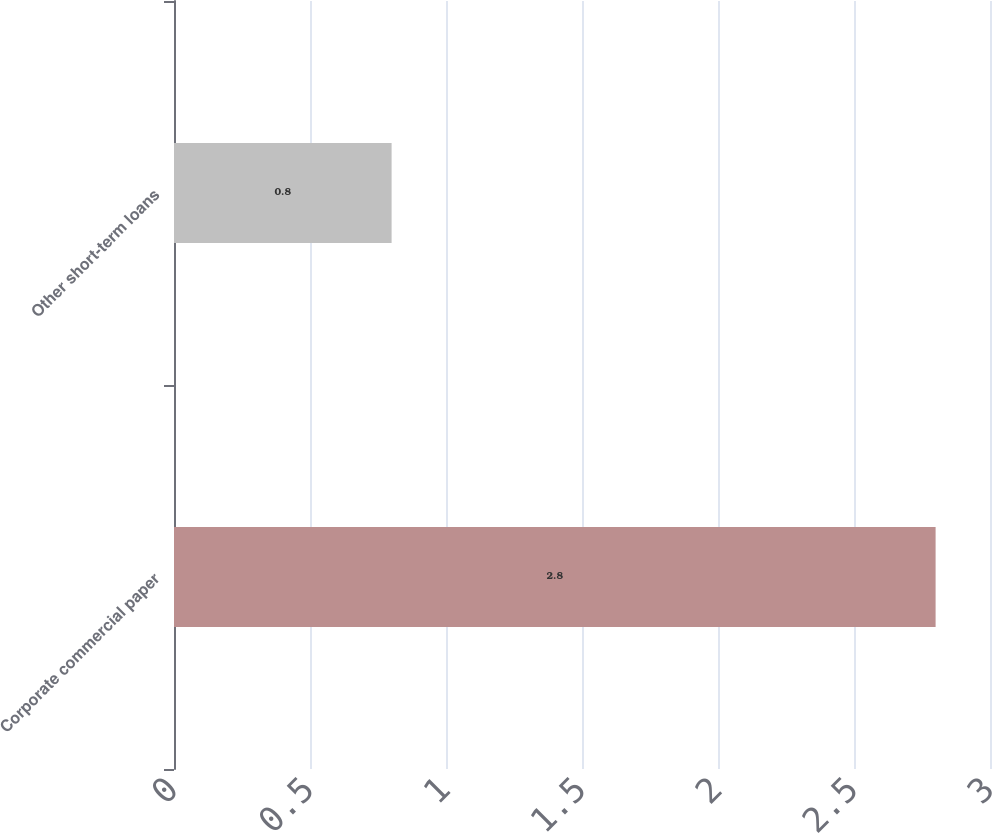<chart> <loc_0><loc_0><loc_500><loc_500><bar_chart><fcel>Corporate commercial paper<fcel>Other short-term loans<nl><fcel>2.8<fcel>0.8<nl></chart> 